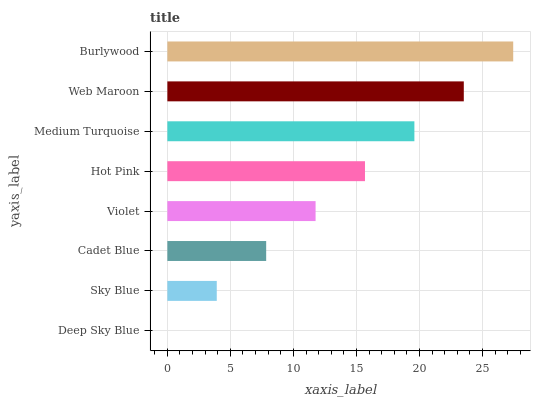Is Deep Sky Blue the minimum?
Answer yes or no. Yes. Is Burlywood the maximum?
Answer yes or no. Yes. Is Sky Blue the minimum?
Answer yes or no. No. Is Sky Blue the maximum?
Answer yes or no. No. Is Sky Blue greater than Deep Sky Blue?
Answer yes or no. Yes. Is Deep Sky Blue less than Sky Blue?
Answer yes or no. Yes. Is Deep Sky Blue greater than Sky Blue?
Answer yes or no. No. Is Sky Blue less than Deep Sky Blue?
Answer yes or no. No. Is Hot Pink the high median?
Answer yes or no. Yes. Is Violet the low median?
Answer yes or no. Yes. Is Web Maroon the high median?
Answer yes or no. No. Is Hot Pink the low median?
Answer yes or no. No. 